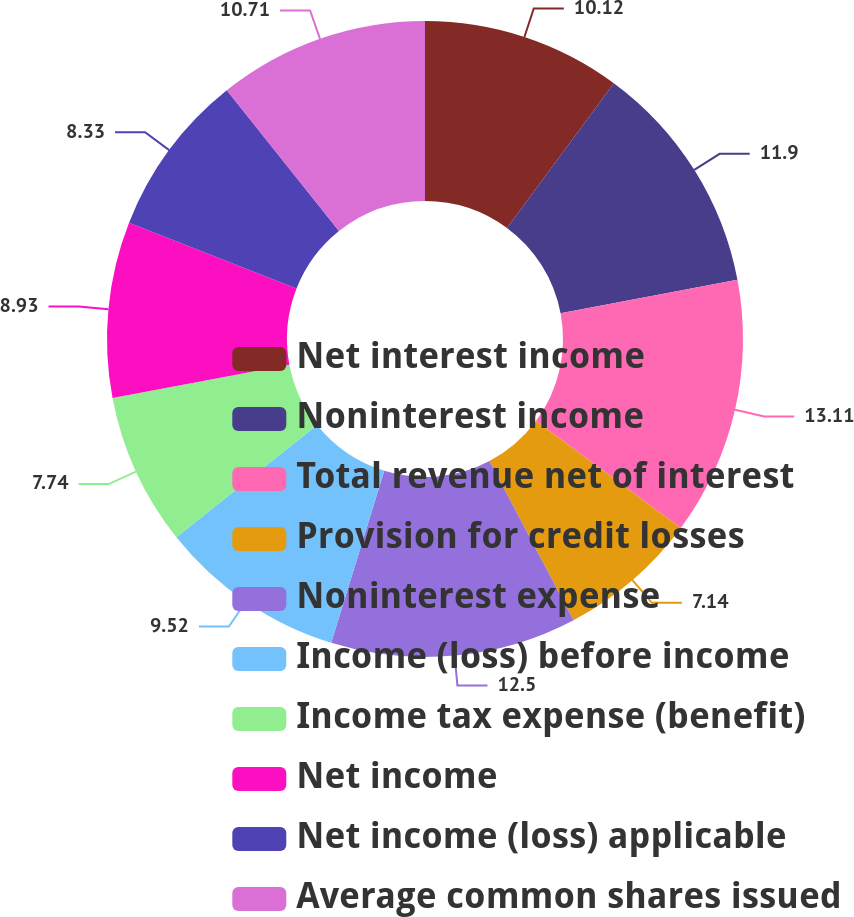<chart> <loc_0><loc_0><loc_500><loc_500><pie_chart><fcel>Net interest income<fcel>Noninterest income<fcel>Total revenue net of interest<fcel>Provision for credit losses<fcel>Noninterest expense<fcel>Income (loss) before income<fcel>Income tax expense (benefit)<fcel>Net income<fcel>Net income (loss) applicable<fcel>Average common shares issued<nl><fcel>10.12%<fcel>11.9%<fcel>13.1%<fcel>7.14%<fcel>12.5%<fcel>9.52%<fcel>7.74%<fcel>8.93%<fcel>8.33%<fcel>10.71%<nl></chart> 